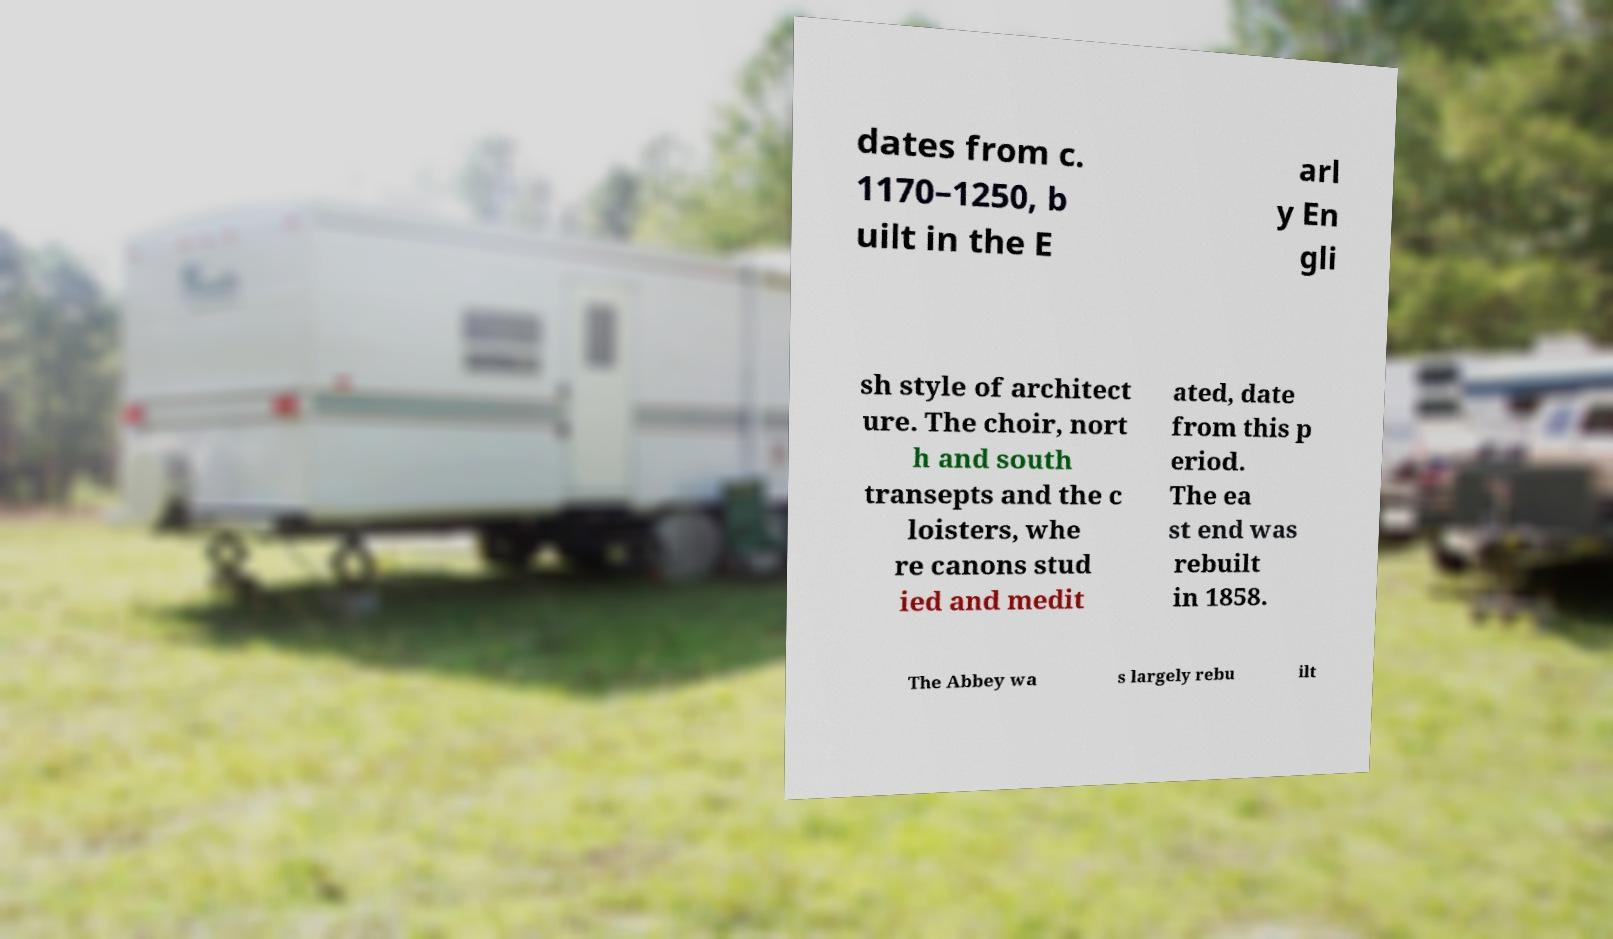Could you extract and type out the text from this image? dates from c. 1170–1250, b uilt in the E arl y En gli sh style of architect ure. The choir, nort h and south transepts and the c loisters, whe re canons stud ied and medit ated, date from this p eriod. The ea st end was rebuilt in 1858. The Abbey wa s largely rebu ilt 